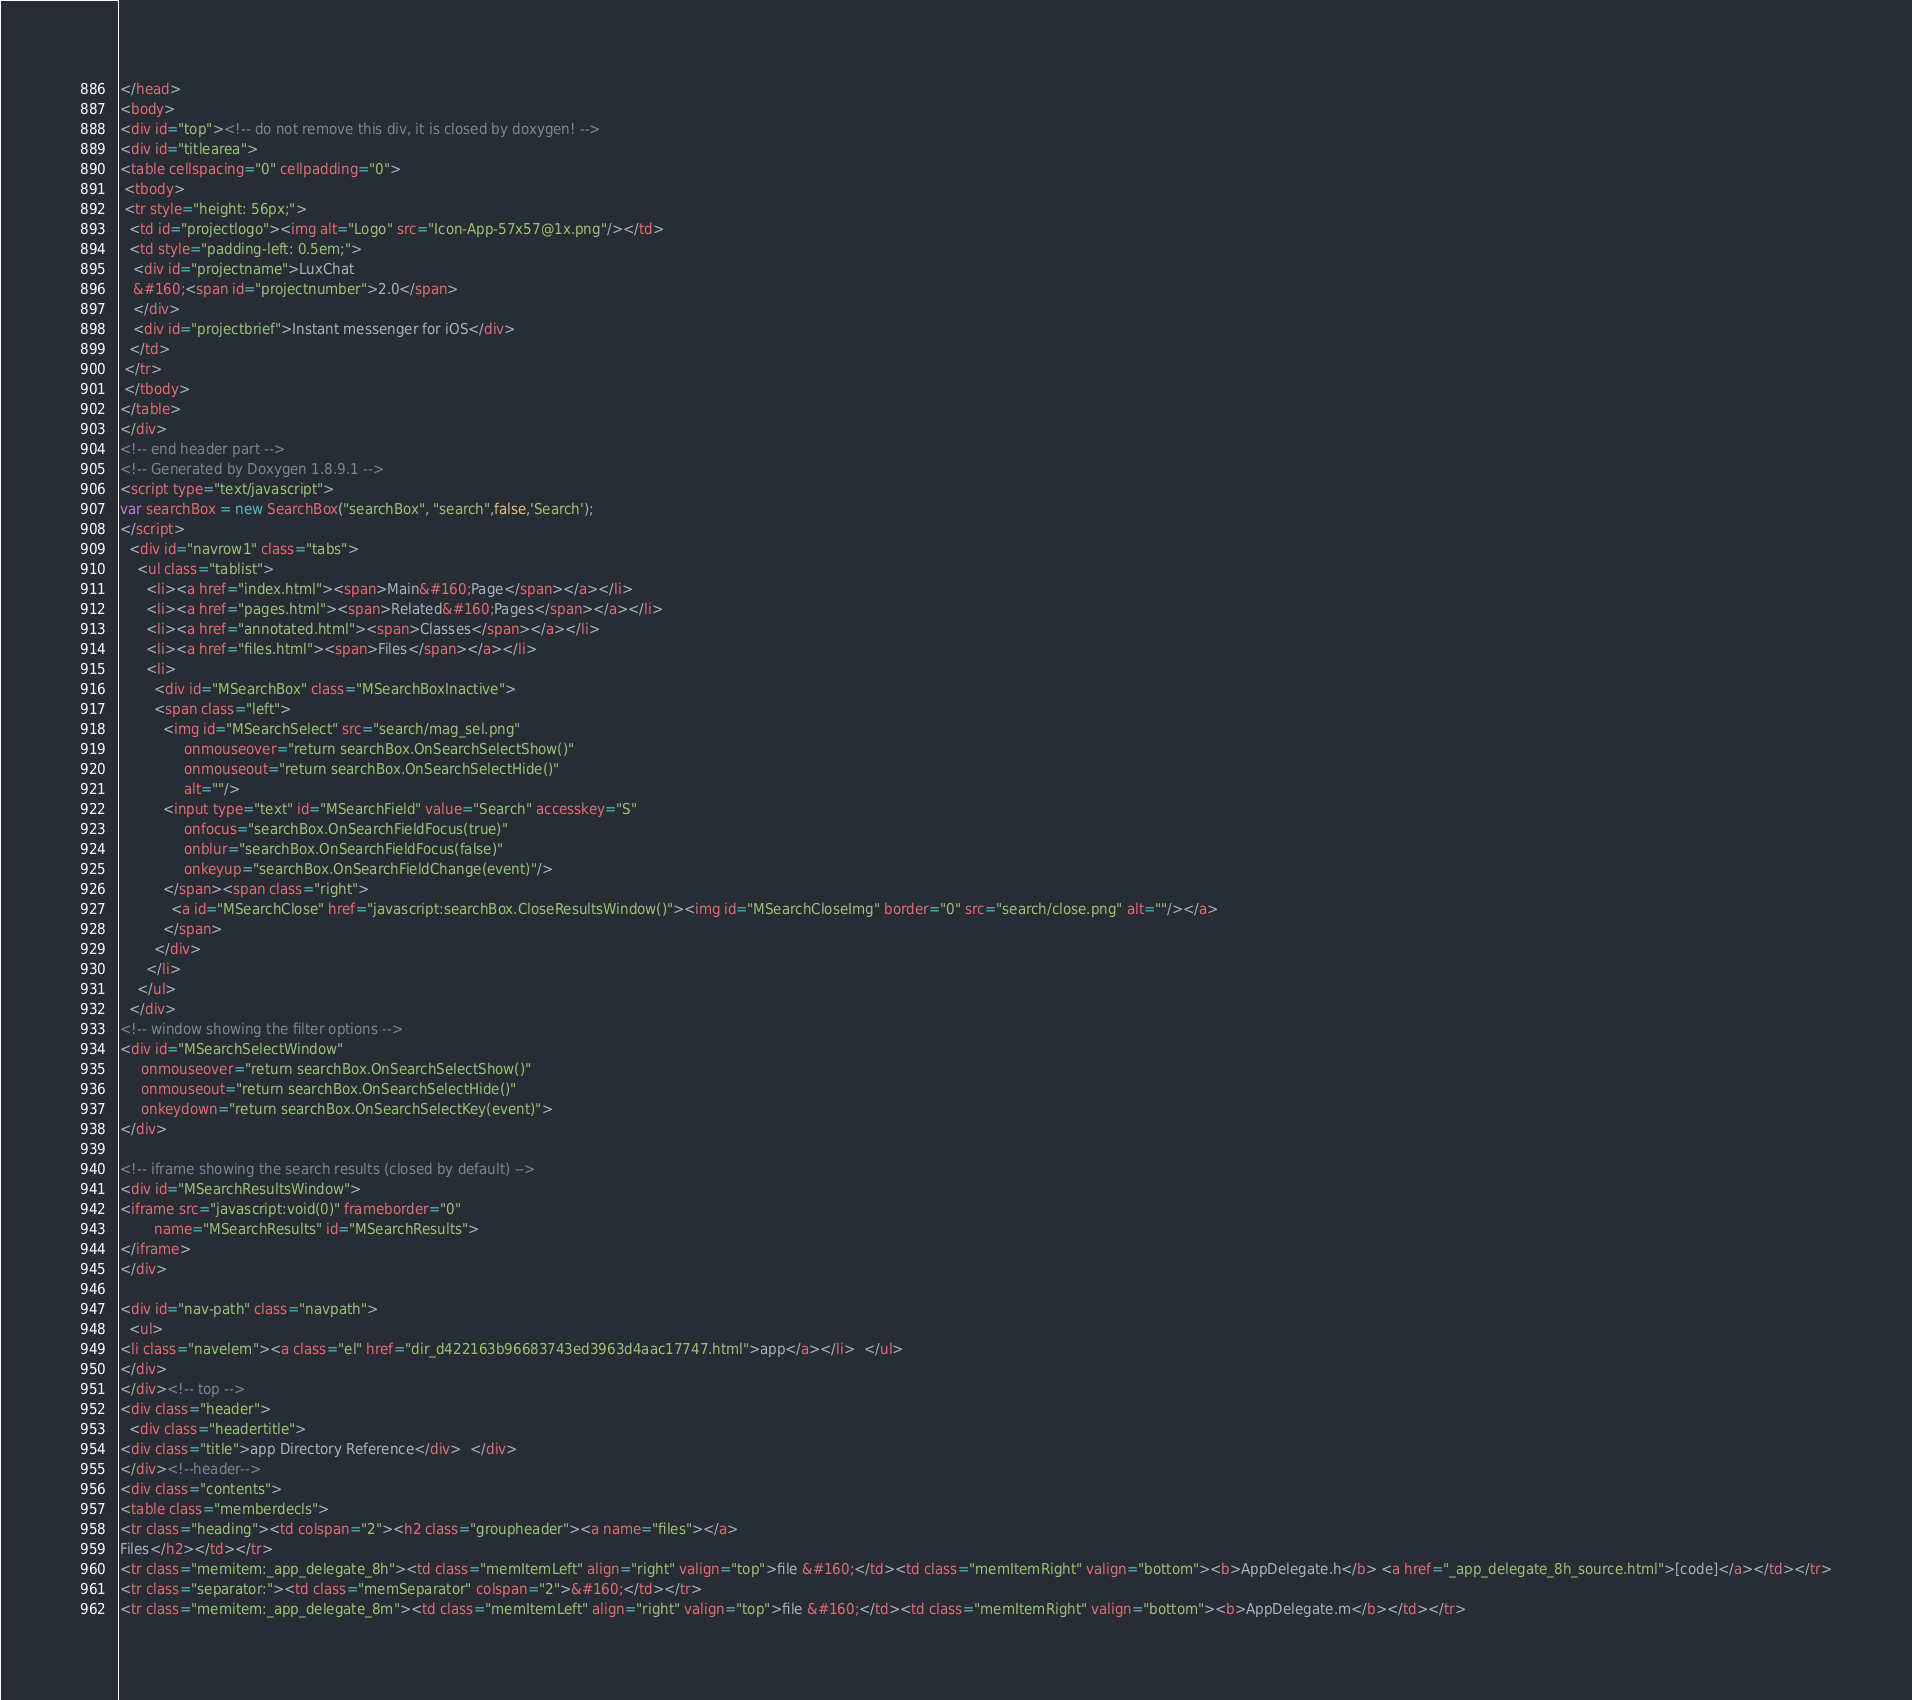<code> <loc_0><loc_0><loc_500><loc_500><_HTML_></head>
<body>
<div id="top"><!-- do not remove this div, it is closed by doxygen! -->
<div id="titlearea">
<table cellspacing="0" cellpadding="0">
 <tbody>
 <tr style="height: 56px;">
  <td id="projectlogo"><img alt="Logo" src="Icon-App-57x57@1x.png"/></td>
  <td style="padding-left: 0.5em;">
   <div id="projectname">LuxChat
   &#160;<span id="projectnumber">2.0</span>
   </div>
   <div id="projectbrief">Instant messenger for iOS</div>
  </td>
 </tr>
 </tbody>
</table>
</div>
<!-- end header part -->
<!-- Generated by Doxygen 1.8.9.1 -->
<script type="text/javascript">
var searchBox = new SearchBox("searchBox", "search",false,'Search');
</script>
  <div id="navrow1" class="tabs">
    <ul class="tablist">
      <li><a href="index.html"><span>Main&#160;Page</span></a></li>
      <li><a href="pages.html"><span>Related&#160;Pages</span></a></li>
      <li><a href="annotated.html"><span>Classes</span></a></li>
      <li><a href="files.html"><span>Files</span></a></li>
      <li>
        <div id="MSearchBox" class="MSearchBoxInactive">
        <span class="left">
          <img id="MSearchSelect" src="search/mag_sel.png"
               onmouseover="return searchBox.OnSearchSelectShow()"
               onmouseout="return searchBox.OnSearchSelectHide()"
               alt=""/>
          <input type="text" id="MSearchField" value="Search" accesskey="S"
               onfocus="searchBox.OnSearchFieldFocus(true)" 
               onblur="searchBox.OnSearchFieldFocus(false)" 
               onkeyup="searchBox.OnSearchFieldChange(event)"/>
          </span><span class="right">
            <a id="MSearchClose" href="javascript:searchBox.CloseResultsWindow()"><img id="MSearchCloseImg" border="0" src="search/close.png" alt=""/></a>
          </span>
        </div>
      </li>
    </ul>
  </div>
<!-- window showing the filter options -->
<div id="MSearchSelectWindow"
     onmouseover="return searchBox.OnSearchSelectShow()"
     onmouseout="return searchBox.OnSearchSelectHide()"
     onkeydown="return searchBox.OnSearchSelectKey(event)">
</div>

<!-- iframe showing the search results (closed by default) -->
<div id="MSearchResultsWindow">
<iframe src="javascript:void(0)" frameborder="0" 
        name="MSearchResults" id="MSearchResults">
</iframe>
</div>

<div id="nav-path" class="navpath">
  <ul>
<li class="navelem"><a class="el" href="dir_d422163b96683743ed3963d4aac17747.html">app</a></li>  </ul>
</div>
</div><!-- top -->
<div class="header">
  <div class="headertitle">
<div class="title">app Directory Reference</div>  </div>
</div><!--header-->
<div class="contents">
<table class="memberdecls">
<tr class="heading"><td colspan="2"><h2 class="groupheader"><a name="files"></a>
Files</h2></td></tr>
<tr class="memitem:_app_delegate_8h"><td class="memItemLeft" align="right" valign="top">file &#160;</td><td class="memItemRight" valign="bottom"><b>AppDelegate.h</b> <a href="_app_delegate_8h_source.html">[code]</a></td></tr>
<tr class="separator:"><td class="memSeparator" colspan="2">&#160;</td></tr>
<tr class="memitem:_app_delegate_8m"><td class="memItemLeft" align="right" valign="top">file &#160;</td><td class="memItemRight" valign="bottom"><b>AppDelegate.m</b></td></tr></code> 